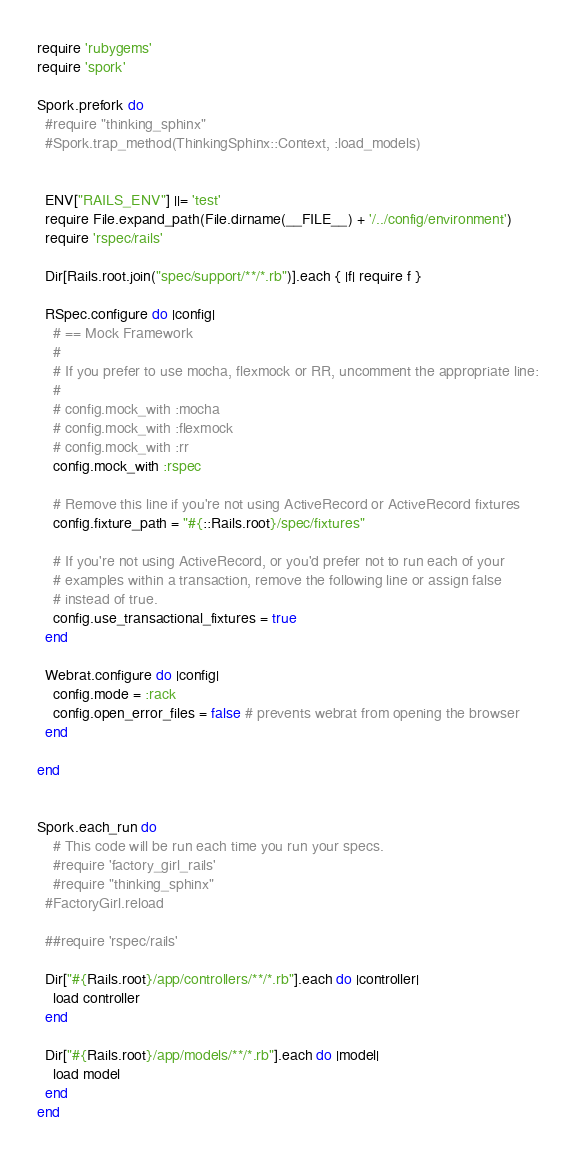<code> <loc_0><loc_0><loc_500><loc_500><_Ruby_>require 'rubygems'
require 'spork'

Spork.prefork do
  #require "thinking_sphinx"
  #Spork.trap_method(ThinkingSphinx::Context, :load_models)


  ENV["RAILS_ENV"] ||= 'test'
  require File.expand_path(File.dirname(__FILE__) + '/../config/environment')
  require 'rspec/rails'

  Dir[Rails.root.join("spec/support/**/*.rb")].each { |f| require f }

  RSpec.configure do |config|
    # == Mock Framework
    #
    # If you prefer to use mocha, flexmock or RR, uncomment the appropriate line:
    #
    # config.mock_with :mocha
    # config.mock_with :flexmock
    # config.mock_with :rr
    config.mock_with :rspec

    # Remove this line if you're not using ActiveRecord or ActiveRecord fixtures
    config.fixture_path = "#{::Rails.root}/spec/fixtures"

    # If you're not using ActiveRecord, or you'd prefer not to run each of your
    # examples within a transaction, remove the following line or assign false
    # instead of true.
    config.use_transactional_fixtures = true
  end

  Webrat.configure do |config|
    config.mode = :rack
    config.open_error_files = false # prevents webrat from opening the browser
  end

end


Spork.each_run do
	# This code will be run each time you run your specs.
	#require 'factory_girl_rails'
	#require "thinking_sphinx"
  #FactoryGirl.reload

  ##require 'rspec/rails'
  
  Dir["#{Rails.root}/app/controllers/**/*.rb"].each do |controller|
    load controller
  end
  
  Dir["#{Rails.root}/app/models/**/*.rb"].each do |model|
    load model
  end
end</code> 